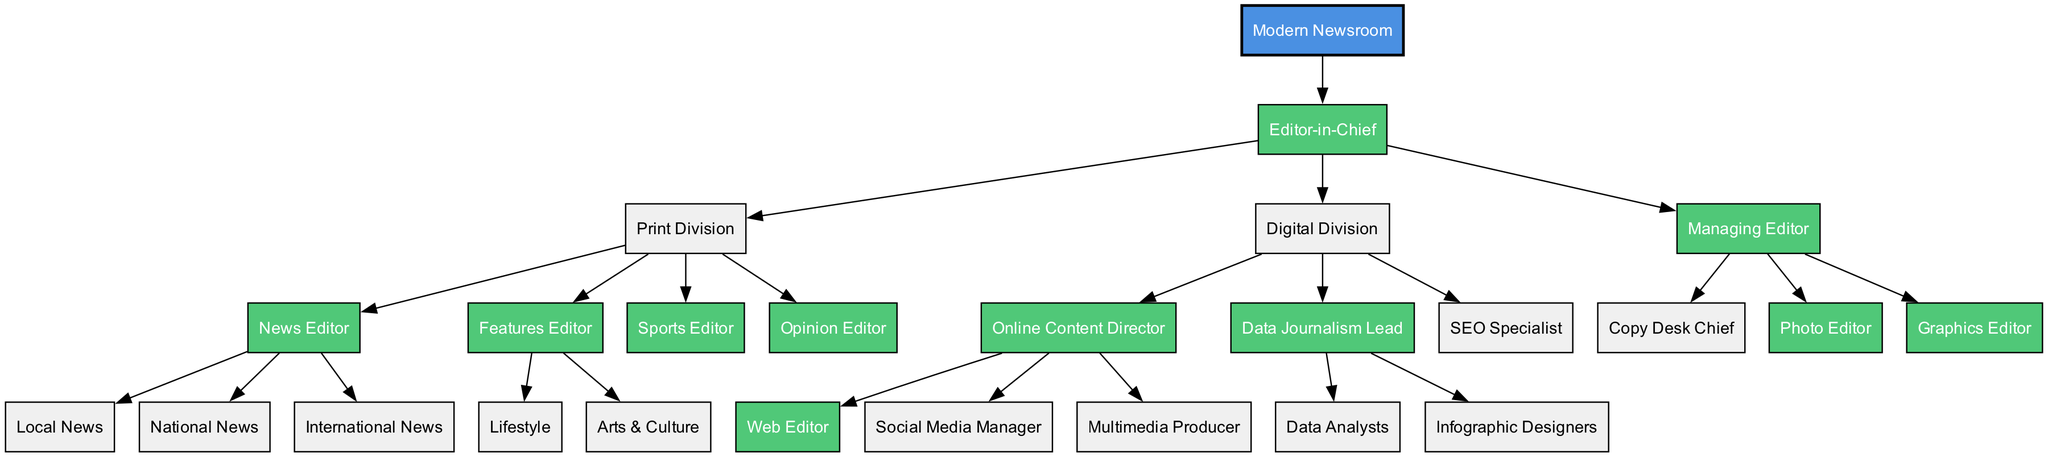What is the top-level position in the organizational structure? The diagram shows "Editor-in-Chief" as the root node, indicating it is the top-level position in the hierarchy.
Answer: Editor-in-Chief How many divisions are there under the Editor-in-Chief? The diagram indicates two primary divisions under the Editor-in-Chief: "Print Division" and "Digital Division". Count these divisions to find the answer.
Answer: 2 Who oversees the online content within the Digital Division? The "Online Content Director" is listed as a child under the Digital Division, signifying they oversee online content.
Answer: Online Content Director Which editor is responsible for local, national, and international news? The node "News Editor" within the Print Division has three children: "Local News", "National News", and "International News". Therefore, the News Editor is responsible for these areas.
Answer: News Editor What positions fall under the Print Division? By examining the Print Division, we see the children nodes include "News Editor", "Features Editor", "Sports Editor", and "Opinion Editor". Listing these, we find all positions that fall under this division.
Answer: News Editor, Features Editor, Sports Editor, Opinion Editor How many roles are there under the Digital Division? The Digital Division has three child nodes: "Online Content Director", "Data Journalism Lead", and "SEO Specialist". Adding these together gives the total number of roles.
Answer: 3 Which role is specifically focused on data journalism? The hierarchy lists the role "Data Journalism Lead" under the Digital Division that specifically mentions data journalism, indicating it is focused on this area.
Answer: Data Journalism Lead How many editors oversee the Managing Editor? Under the Managing Editor, there are three roles: "Copy Desk Chief", "Photo Editor", and "Graphics Editor". Counting these roles provides the answer.
Answer: 3 What are the main areas covered by the Features Editor? The Features Editor is responsible for the areas labeled as "Lifestyle" and "Arts & Culture", which are children of the Features Editor in the diagram.
Answer: Lifestyle, Arts & Culture 